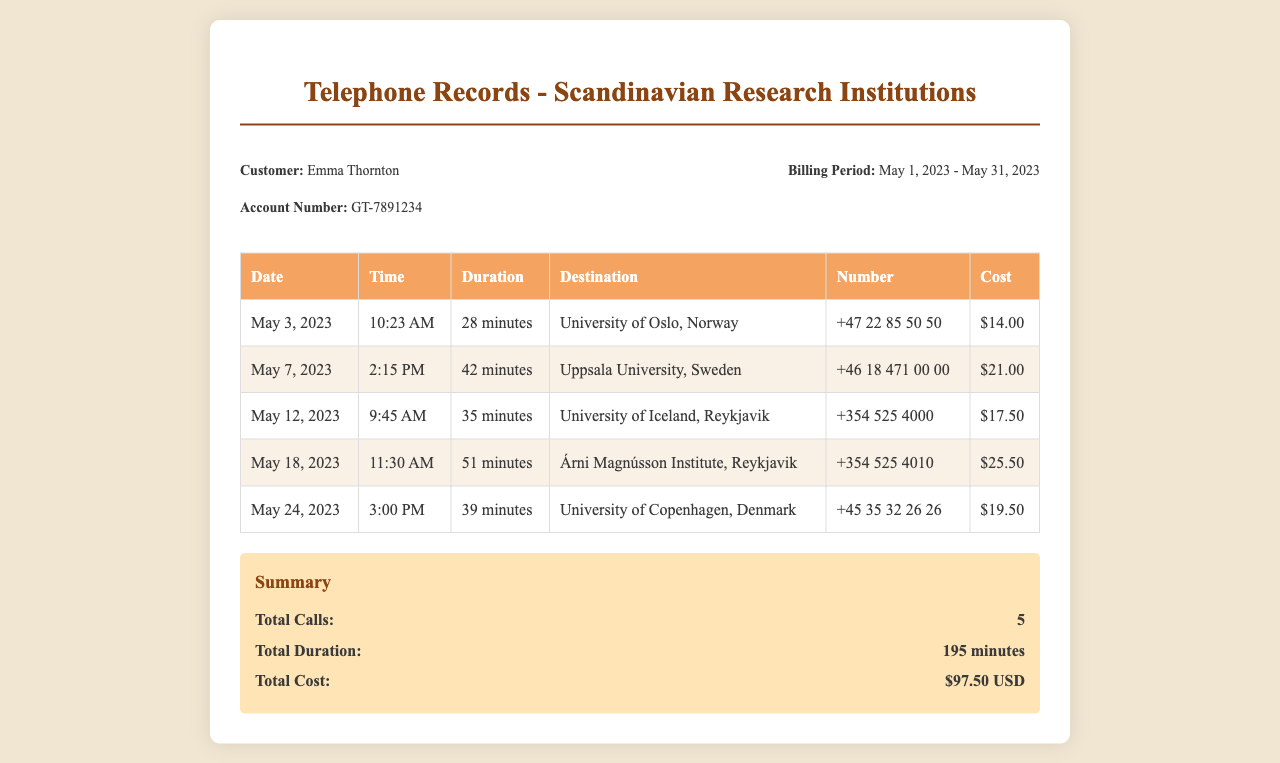What is the name of the customer? The document states the customer's name as Emma Thornton.
Answer: Emma Thornton How many calls were made in total? The summary section of the document indicates there were a total of 5 calls made.
Answer: 5 What is the duration of the call to the University of Copenhagen? The call to the University of Copenhagen lasted for 39 minutes as listed in the table.
Answer: 39 minutes What was the cost of the call to the University of Iceland? The call to the University of Iceland cost $17.50 according to the document.
Answer: $17.50 On what date was the call to Uppsala University made? The call to Uppsala University was made on May 7, 2023, as shown in the table.
Answer: May 7, 2023 What is the total duration of all calls combined? The total duration is provided in the summary section, which states 195 minutes.
Answer: 195 minutes Which institution was contacted on May 12, 2023? The document shows that the call on May 12, 2023, was to the University of Iceland.
Answer: University of Iceland Which call had the highest cost? The call to Árni Magnússon Institute had the highest cost of $25.50 as per the records.
Answer: $25.50 